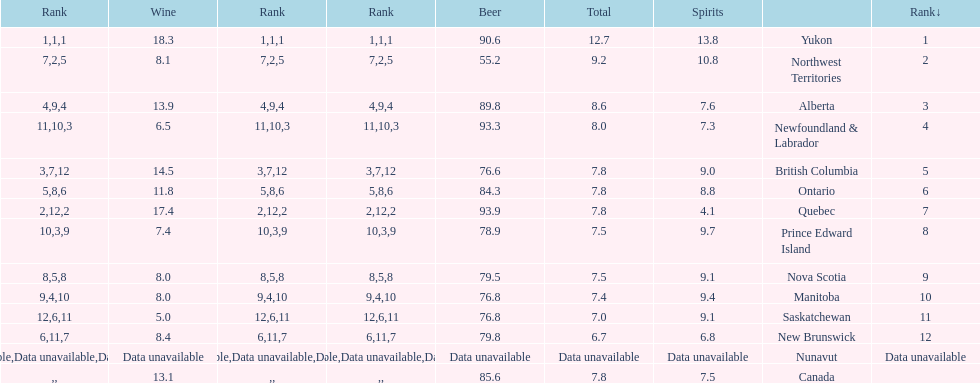Which province is the top consumer of wine? Yukon. 